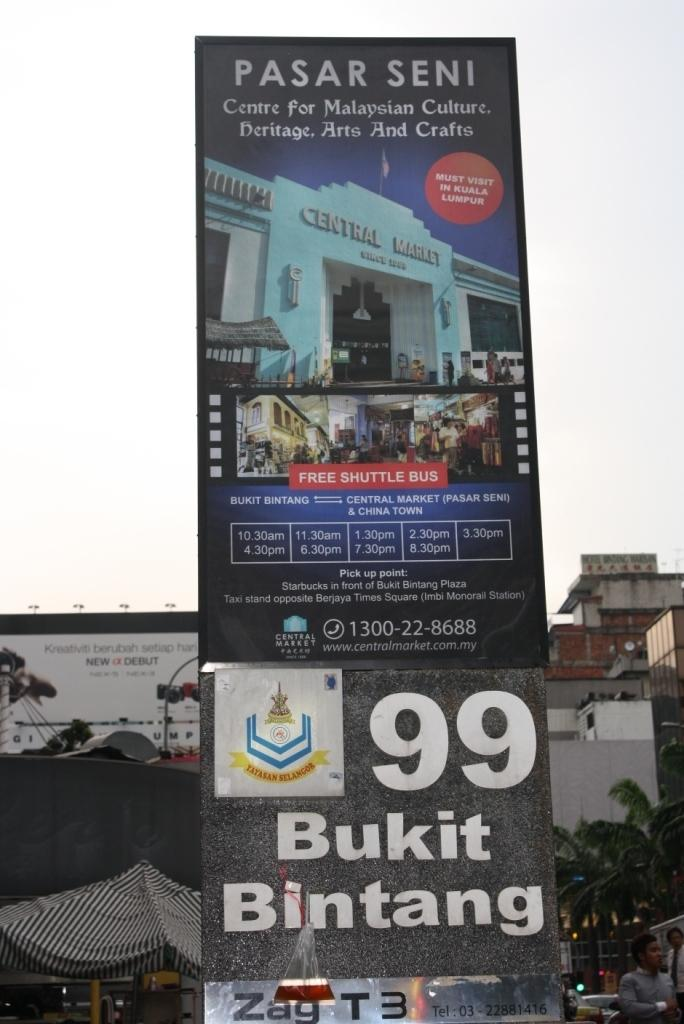Provide a one-sentence caption for the provided image. An event in a big city with a billboard sign that reads Bukit Bintang. 